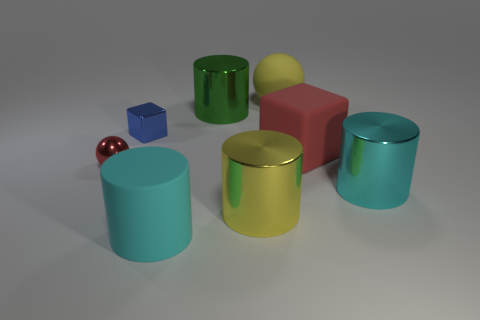How many objects in the image have a reflective surface? Each object in the image exhibits a reflective surface. Counting all of them, there are a total of seven objects with reflective surfaces. 